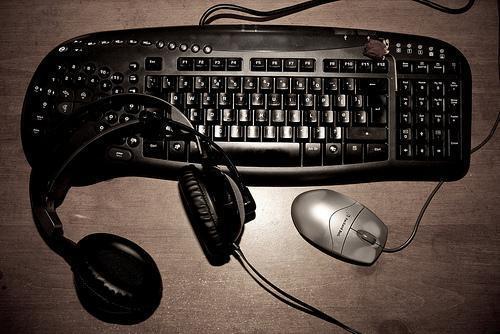How many items are in the picture?
Give a very brief answer. 3. 